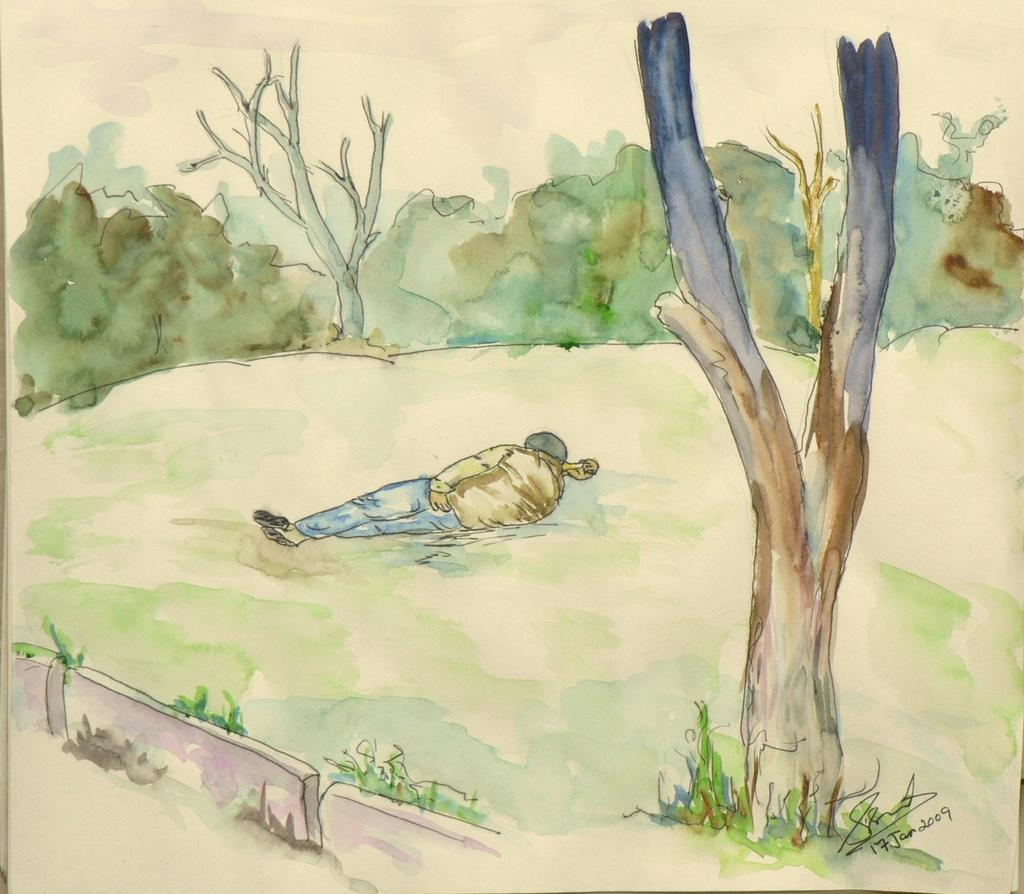What is the main subject of the image? There is a painting in the image. What is the person in the image doing? A person is lying on the grass in the image. What type of natural elements can be seen in the image? There are trees in the image. Can you identify any specific details about the painting? The painting has a signature. What is the limit or boundary of the person's run in the image? There is no person running in the image; the person is lying on the grass. How does the signature on the painting affect the person's ability to run in the image? The signature on the painting does not affect the person's ability to run, as the person is not running in the image. 